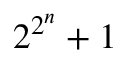Convert formula to latex. <formula><loc_0><loc_0><loc_500><loc_500>2 ^ { 2 ^ { n } } + 1</formula> 